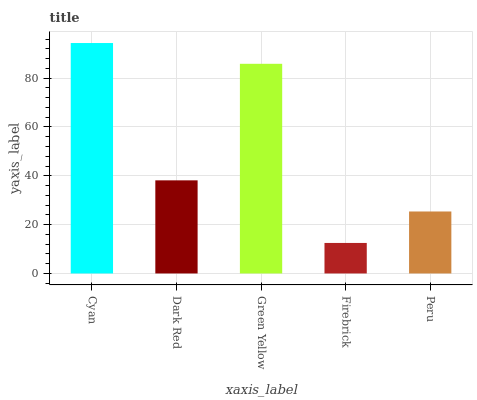Is Firebrick the minimum?
Answer yes or no. Yes. Is Cyan the maximum?
Answer yes or no. Yes. Is Dark Red the minimum?
Answer yes or no. No. Is Dark Red the maximum?
Answer yes or no. No. Is Cyan greater than Dark Red?
Answer yes or no. Yes. Is Dark Red less than Cyan?
Answer yes or no. Yes. Is Dark Red greater than Cyan?
Answer yes or no. No. Is Cyan less than Dark Red?
Answer yes or no. No. Is Dark Red the high median?
Answer yes or no. Yes. Is Dark Red the low median?
Answer yes or no. Yes. Is Cyan the high median?
Answer yes or no. No. Is Firebrick the low median?
Answer yes or no. No. 